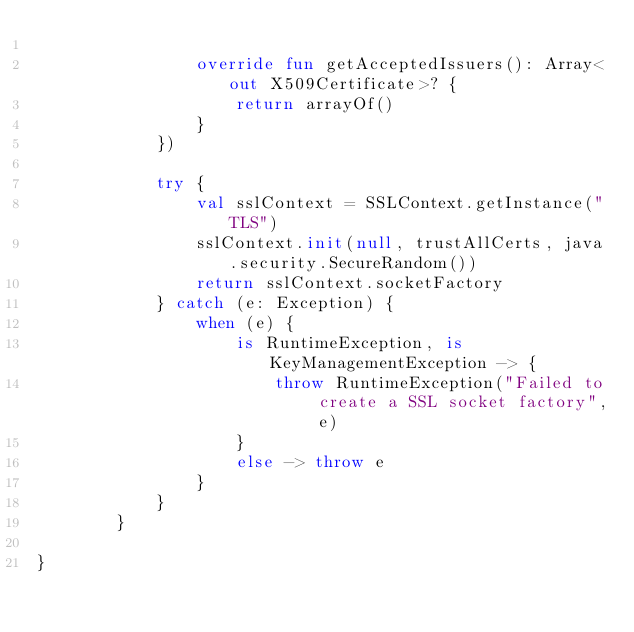Convert code to text. <code><loc_0><loc_0><loc_500><loc_500><_Kotlin_>
                override fun getAcceptedIssuers(): Array<out X509Certificate>? {
                    return arrayOf()
                }
            })

            try {
                val sslContext = SSLContext.getInstance("TLS")
                sslContext.init(null, trustAllCerts, java.security.SecureRandom())
                return sslContext.socketFactory
            } catch (e: Exception) {
                when (e) {
                    is RuntimeException, is KeyManagementException -> {
                        throw RuntimeException("Failed to create a SSL socket factory", e)
                    }
                    else -> throw e
                }
            }
        }

}
</code> 